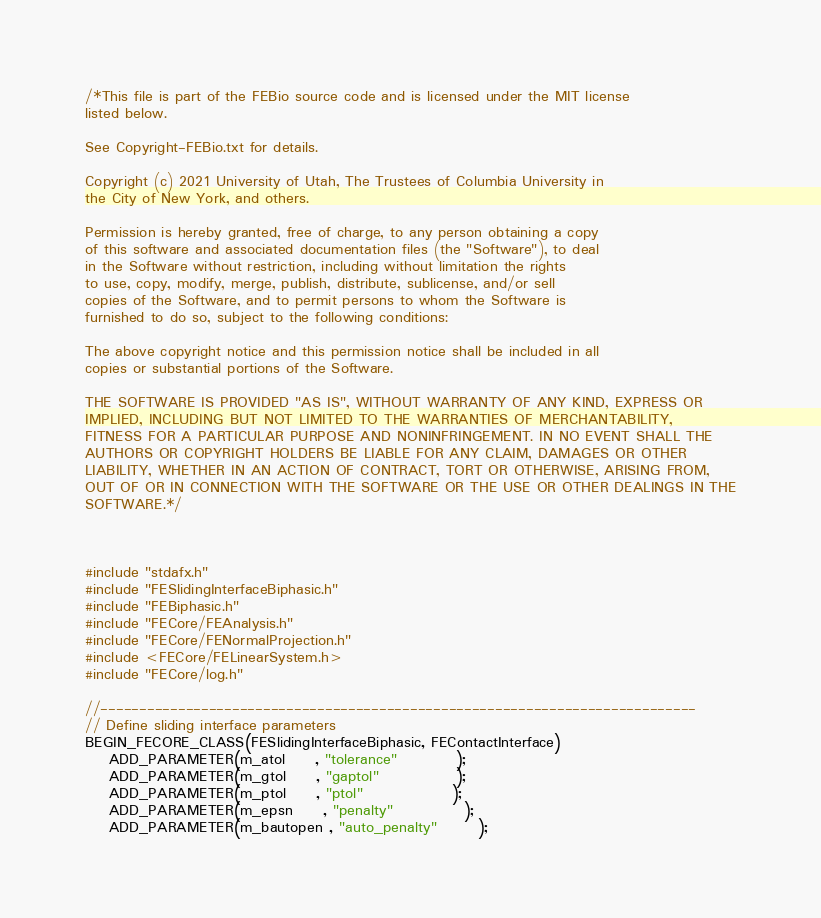Convert code to text. <code><loc_0><loc_0><loc_500><loc_500><_C++_>/*This file is part of the FEBio source code and is licensed under the MIT license
listed below.

See Copyright-FEBio.txt for details.

Copyright (c) 2021 University of Utah, The Trustees of Columbia University in
the City of New York, and others.

Permission is hereby granted, free of charge, to any person obtaining a copy
of this software and associated documentation files (the "Software"), to deal
in the Software without restriction, including without limitation the rights
to use, copy, modify, merge, publish, distribute, sublicense, and/or sell
copies of the Software, and to permit persons to whom the Software is
furnished to do so, subject to the following conditions:

The above copyright notice and this permission notice shall be included in all
copies or substantial portions of the Software.

THE SOFTWARE IS PROVIDED "AS IS", WITHOUT WARRANTY OF ANY KIND, EXPRESS OR
IMPLIED, INCLUDING BUT NOT LIMITED TO THE WARRANTIES OF MERCHANTABILITY,
FITNESS FOR A PARTICULAR PURPOSE AND NONINFRINGEMENT. IN NO EVENT SHALL THE
AUTHORS OR COPYRIGHT HOLDERS BE LIABLE FOR ANY CLAIM, DAMAGES OR OTHER
LIABILITY, WHETHER IN AN ACTION OF CONTRACT, TORT OR OTHERWISE, ARISING FROM,
OUT OF OR IN CONNECTION WITH THE SOFTWARE OR THE USE OR OTHER DEALINGS IN THE
SOFTWARE.*/



#include "stdafx.h"
#include "FESlidingInterfaceBiphasic.h"
#include "FEBiphasic.h"
#include "FECore/FEAnalysis.h"
#include "FECore/FENormalProjection.h"
#include <FECore/FELinearSystem.h>
#include "FECore/log.h"

//-----------------------------------------------------------------------------
// Define sliding interface parameters
BEGIN_FECORE_CLASS(FESlidingInterfaceBiphasic, FEContactInterface)
	ADD_PARAMETER(m_atol     , "tolerance"          );
	ADD_PARAMETER(m_gtol     , "gaptol"             );
	ADD_PARAMETER(m_ptol     , "ptol"               );
	ADD_PARAMETER(m_epsn     , "penalty"            );
	ADD_PARAMETER(m_bautopen , "auto_penalty"       );</code> 